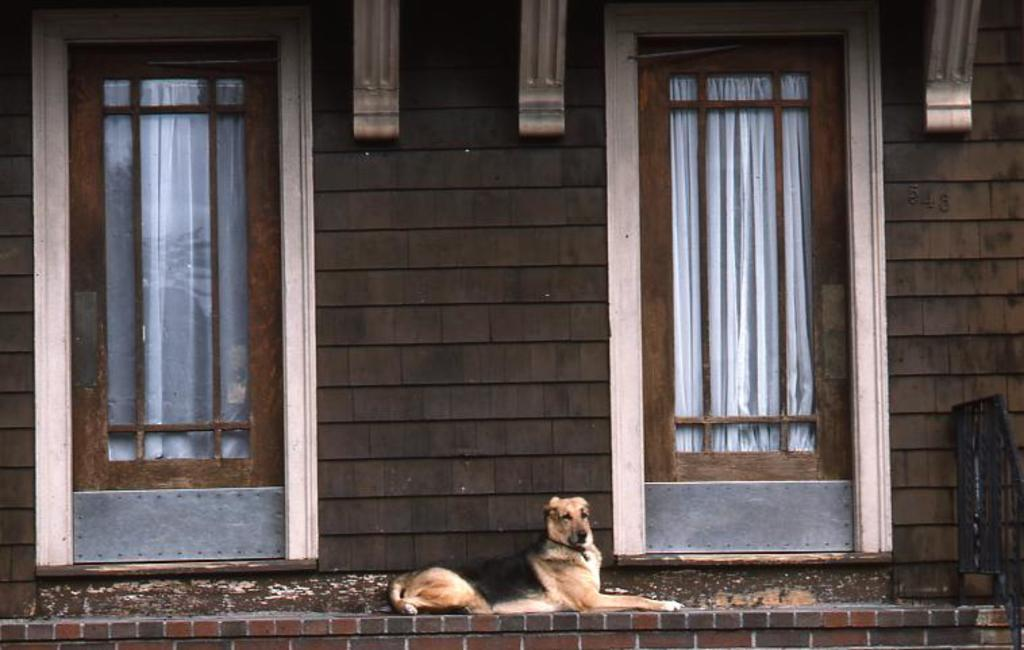What animal can be seen in the image? There is a dog in the image. What is the dog doing in the image? The dog is sitting on a wall. What type of structure is the wall part of? There are glass doors on either side of the wall. How does the dog's fear of cabbage manifest in the image? There is no mention of cabbage or fear in the image, so it cannot be determined how the dog might react to cabbage. 